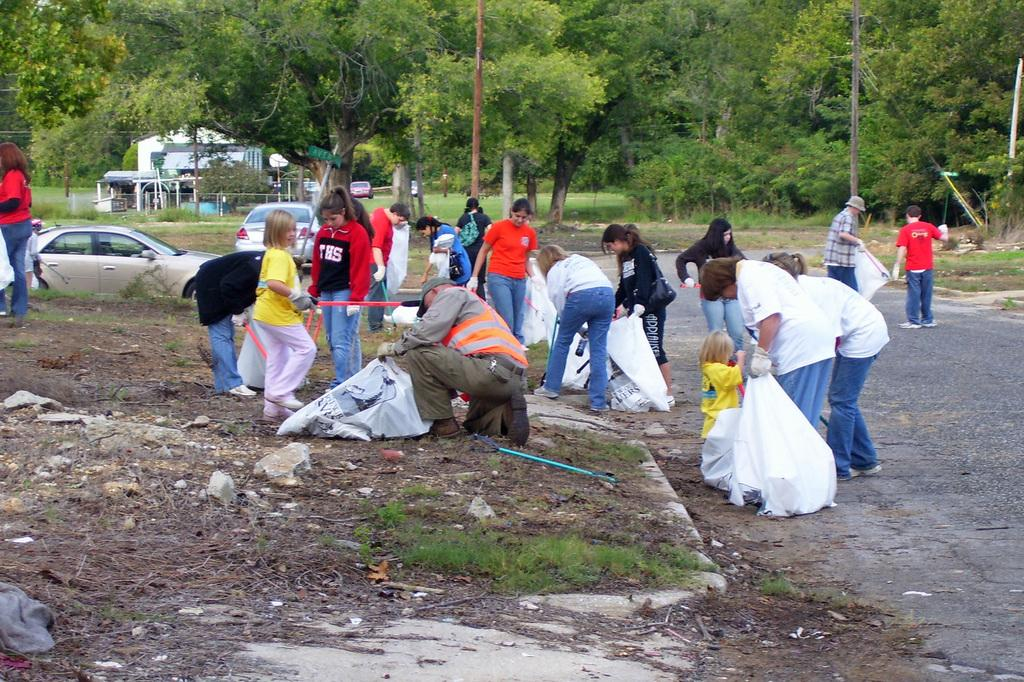How many people are in the image? There are persons in the image, but the exact number is not specified. What are some of the persons holding in the image? Some of the persons are holding bags in the image. What else can be seen in the image besides the persons? There are cars in the image. What can be seen in the background of the image? There are trees and a building in the background of the image. What is the income of the persons in the image? There is no information about the income of the persons in the image. How does the experience of the persons in the image increase over time? The facts provided do not give any information about the experience of the persons or how it might increase over time. 